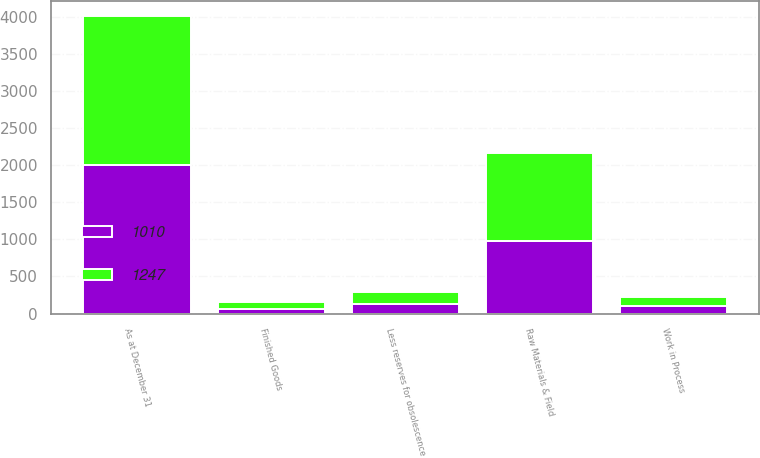<chart> <loc_0><loc_0><loc_500><loc_500><stacked_bar_chart><ecel><fcel>As at December 31<fcel>Raw Materials & Field<fcel>Work in Process<fcel>Finished Goods<fcel>Less reserves for obsolescence<nl><fcel>1247<fcel>2006<fcel>1186<fcel>127<fcel>91<fcel>157<nl><fcel>1010<fcel>2005<fcel>976<fcel>96<fcel>65<fcel>127<nl></chart> 